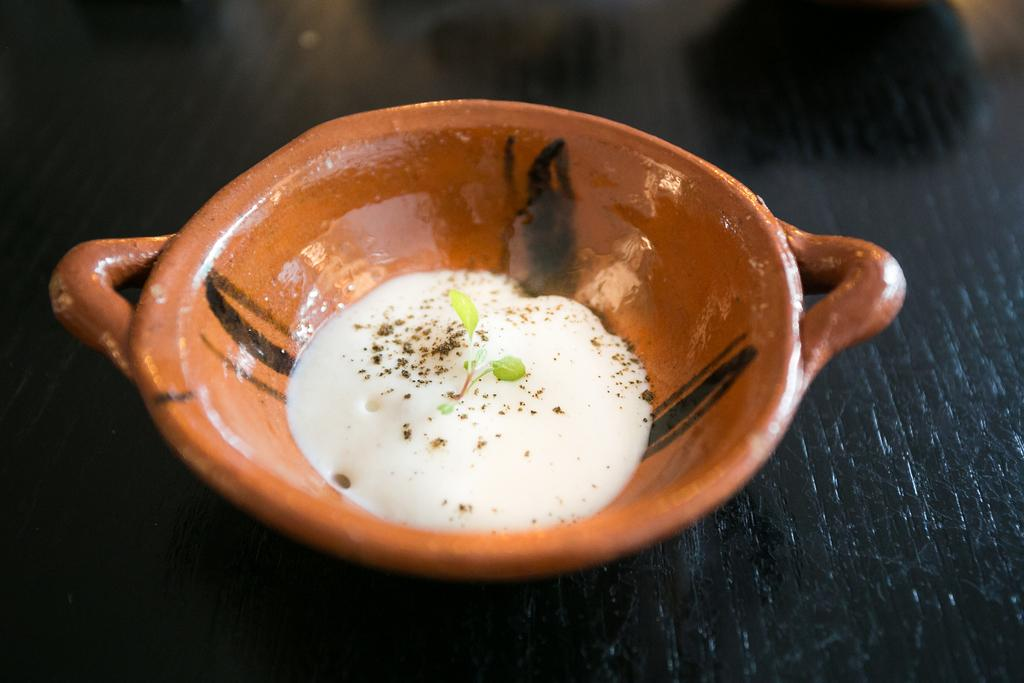What is the color of the container in the image? The container in the image is brown. What is the container placed on in the image? The brown container is kept on a black surface. Are there any bookshelves or a library visible in the image? There is no mention of bookshelves or a library in the provided facts, so we cannot determine if they are present in the image. 